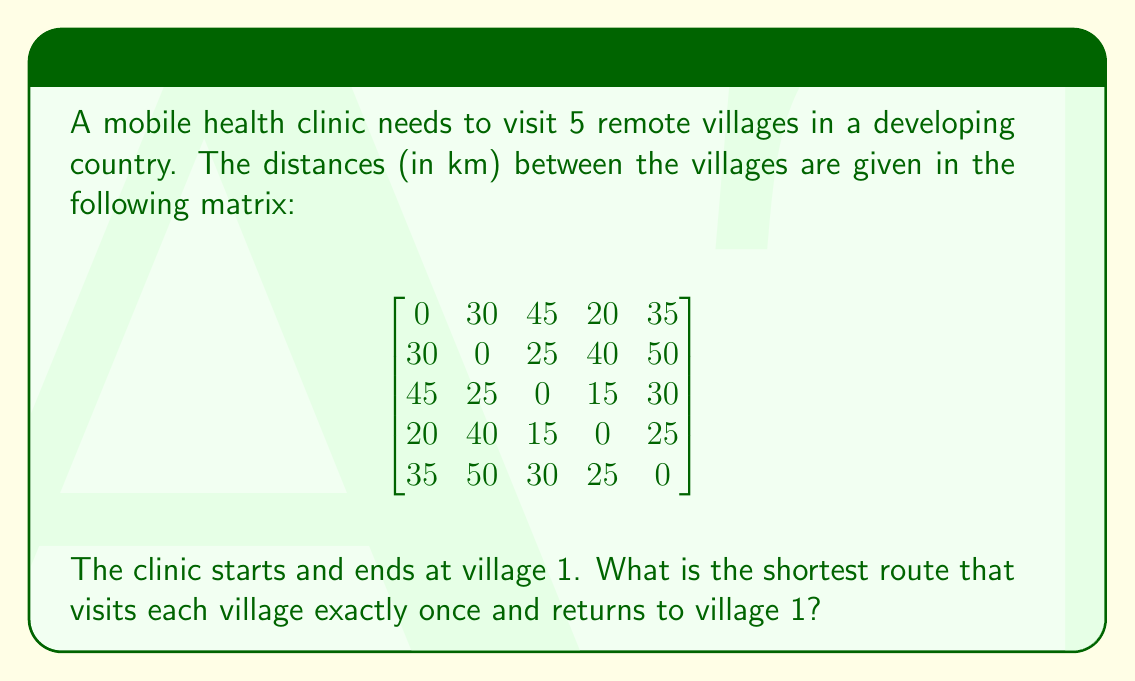Show me your answer to this math problem. This problem is an instance of the Traveling Salesman Problem (TSP). To solve it, we can use the following steps:

1. Identify all possible routes:
   There are $(5-1)! = 24$ possible routes, as the start and end points are fixed.

2. Calculate the total distance for each route:
   For example, the route 1-2-3-4-5-1 would have a distance of:
   $30 + 25 + 15 + 25 + 35 = 130$ km

3. Compare all routes to find the shortest:
   After calculating all 24 routes, we find the shortest one.

The complete enumeration of all routes:

1-2-3-4-5-1: 130 km
1-2-3-5-4-1: 140 km
1-2-4-3-5-1: 140 km
1-2-4-5-3-1: 155 km
1-2-5-3-4-1: 130 km
1-2-5-4-3-1: 145 km
1-3-2-4-5-1: 155 km
1-3-2-5-4-1: 165 km
1-3-4-2-5-1: 140 km
1-3-4-5-2-1: 135 km
1-3-5-2-4-1: 160 km
1-3-5-4-2-1: 145 km
1-4-2-3-5-1: 140 km
1-4-2-5-3-1: 150 km
1-4-3-2-5-1: 140 km
1-4-3-5-2-1: 130 km
1-4-5-2-3-1: 150 km
1-4-5-3-2-1: 135 km
1-5-2-3-4-1: 145 km
1-5-2-4-3-1: 150 km
1-5-3-2-4-1: 150 km
1-5-3-4-2-1: 135 km
1-5-4-2-3-1: 150 km
1-5-4-3-2-1: 130 km

The shortest routes are 1-2-3-4-5-1, 1-2-5-3-4-1, 1-4-3-5-2-1, and 1-5-4-3-2-1, all with a total distance of 130 km.
Answer: The shortest route is 130 km, which can be achieved by following any of these paths: 1-2-3-4-5-1, 1-2-5-3-4-1, 1-4-3-5-2-1, or 1-5-4-3-2-1. 